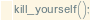Convert code to text. <code><loc_0><loc_0><loc_500><loc_500><_JavaScript_>kill_yourself();</code> 